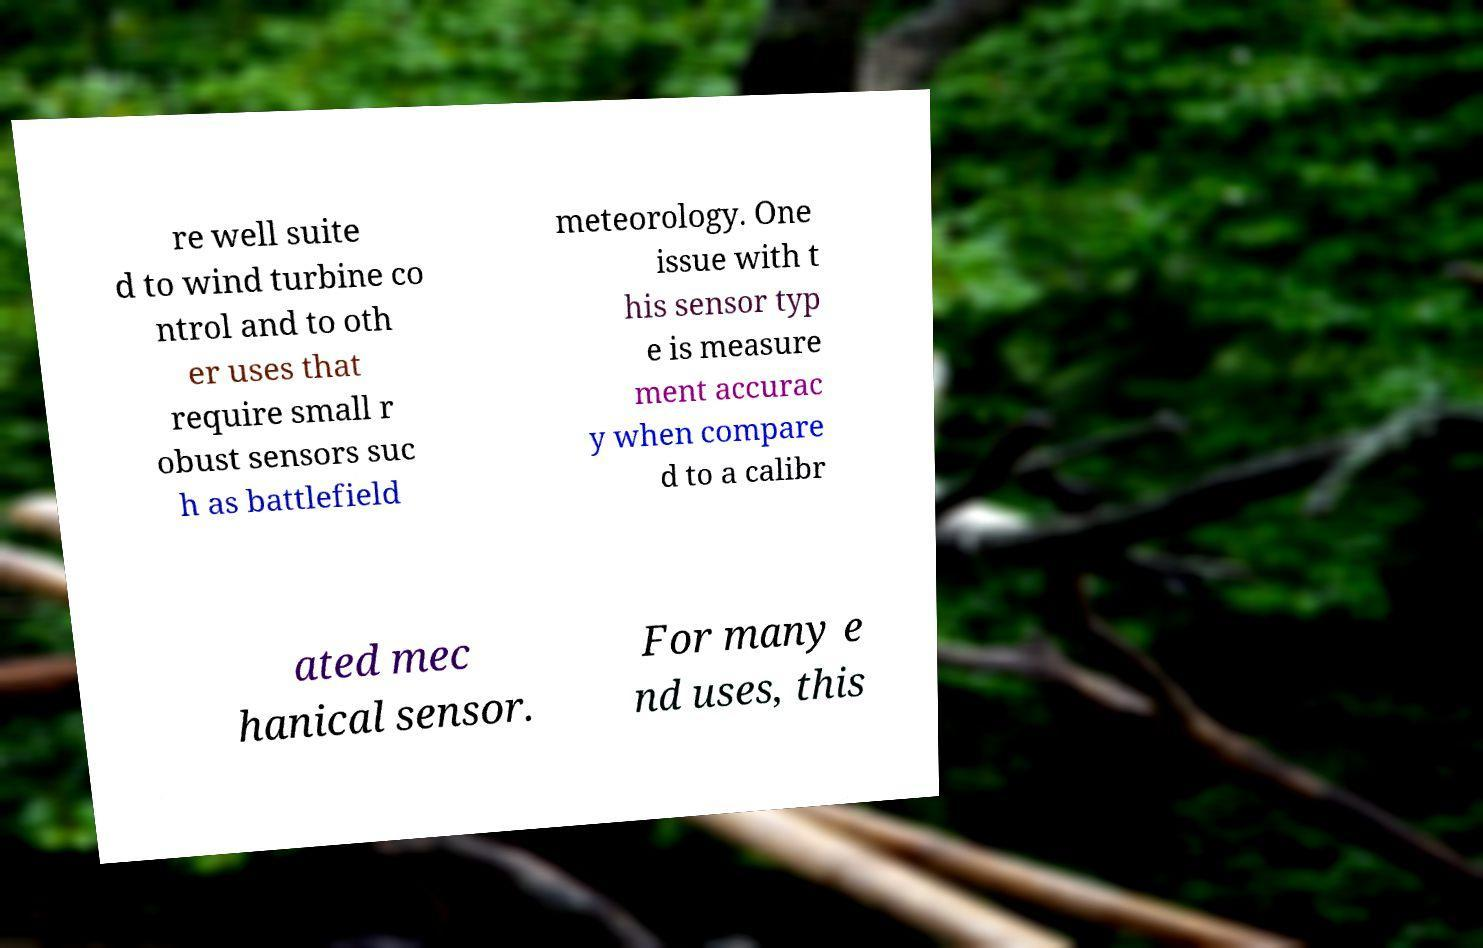Can you read and provide the text displayed in the image?This photo seems to have some interesting text. Can you extract and type it out for me? re well suite d to wind turbine co ntrol and to oth er uses that require small r obust sensors suc h as battlefield meteorology. One issue with t his sensor typ e is measure ment accurac y when compare d to a calibr ated mec hanical sensor. For many e nd uses, this 